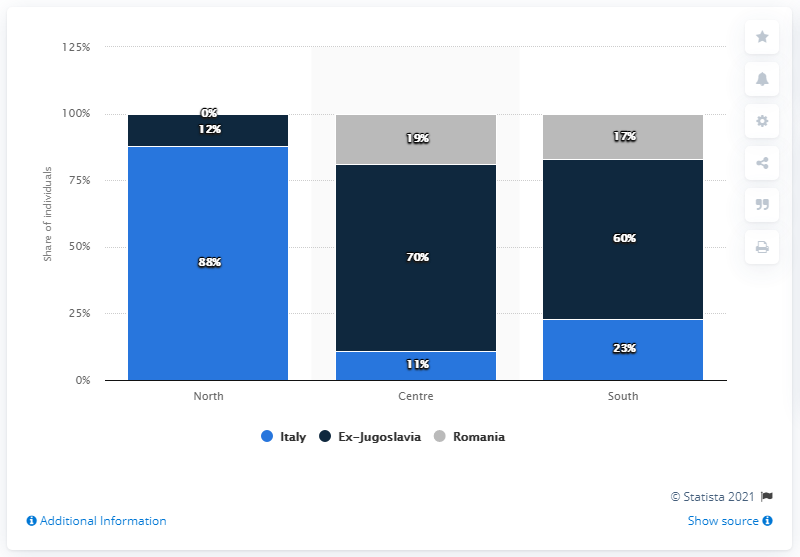Give some essential details in this illustration. In 2019, the percentage of people with Italian nationality in North-Italy was approximately 88%. 